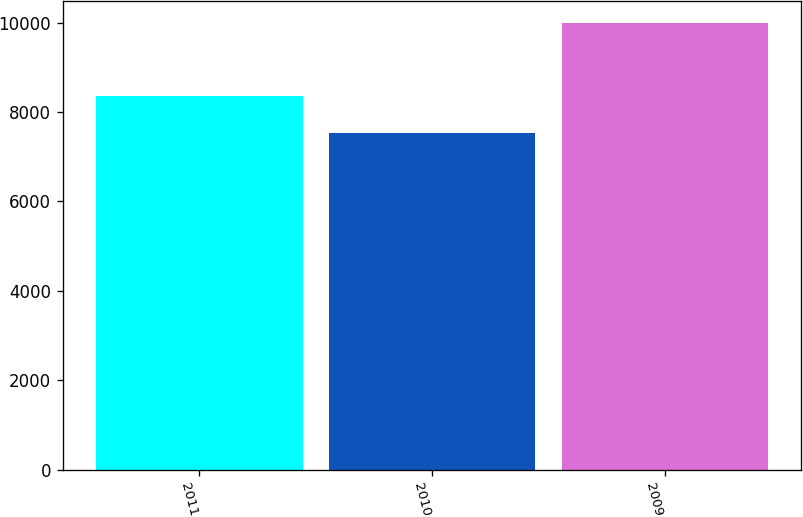Convert chart to OTSL. <chart><loc_0><loc_0><loc_500><loc_500><bar_chart><fcel>2011<fcel>2010<fcel>2009<nl><fcel>8368<fcel>7535<fcel>9983<nl></chart> 